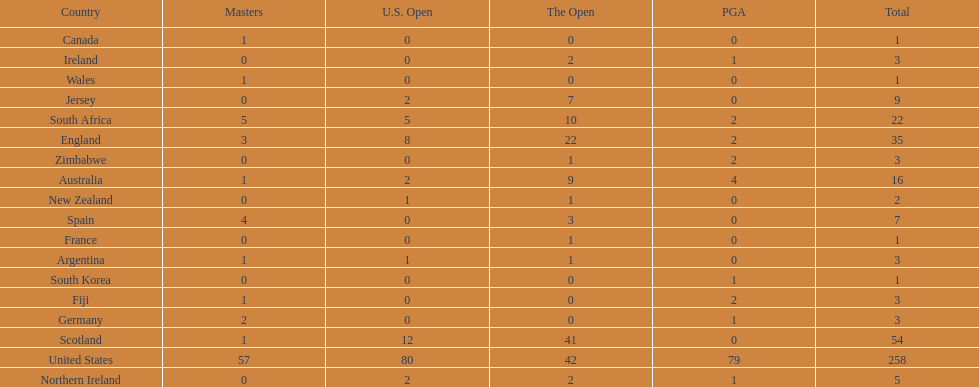How many total championships does spain have? 7. 